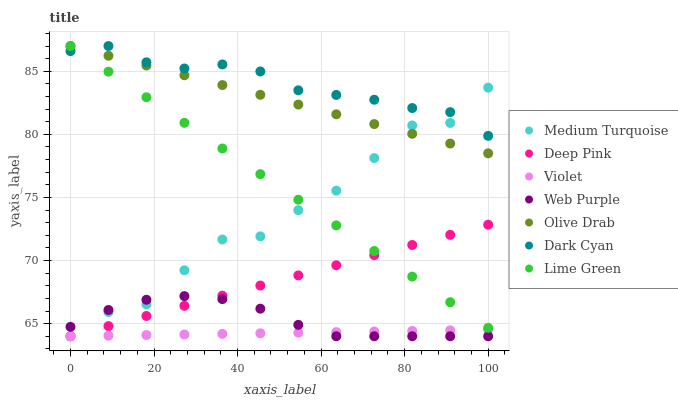Does Violet have the minimum area under the curve?
Answer yes or no. Yes. Does Dark Cyan have the maximum area under the curve?
Answer yes or no. Yes. Does Web Purple have the minimum area under the curve?
Answer yes or no. No. Does Web Purple have the maximum area under the curve?
Answer yes or no. No. Is Violet the smoothest?
Answer yes or no. Yes. Is Medium Turquoise the roughest?
Answer yes or no. Yes. Is Web Purple the smoothest?
Answer yes or no. No. Is Web Purple the roughest?
Answer yes or no. No. Does Deep Pink have the lowest value?
Answer yes or no. Yes. Does Dark Cyan have the lowest value?
Answer yes or no. No. Does Olive Drab have the highest value?
Answer yes or no. Yes. Does Web Purple have the highest value?
Answer yes or no. No. Is Web Purple less than Olive Drab?
Answer yes or no. Yes. Is Lime Green greater than Violet?
Answer yes or no. Yes. Does Lime Green intersect Dark Cyan?
Answer yes or no. Yes. Is Lime Green less than Dark Cyan?
Answer yes or no. No. Is Lime Green greater than Dark Cyan?
Answer yes or no. No. Does Web Purple intersect Olive Drab?
Answer yes or no. No. 